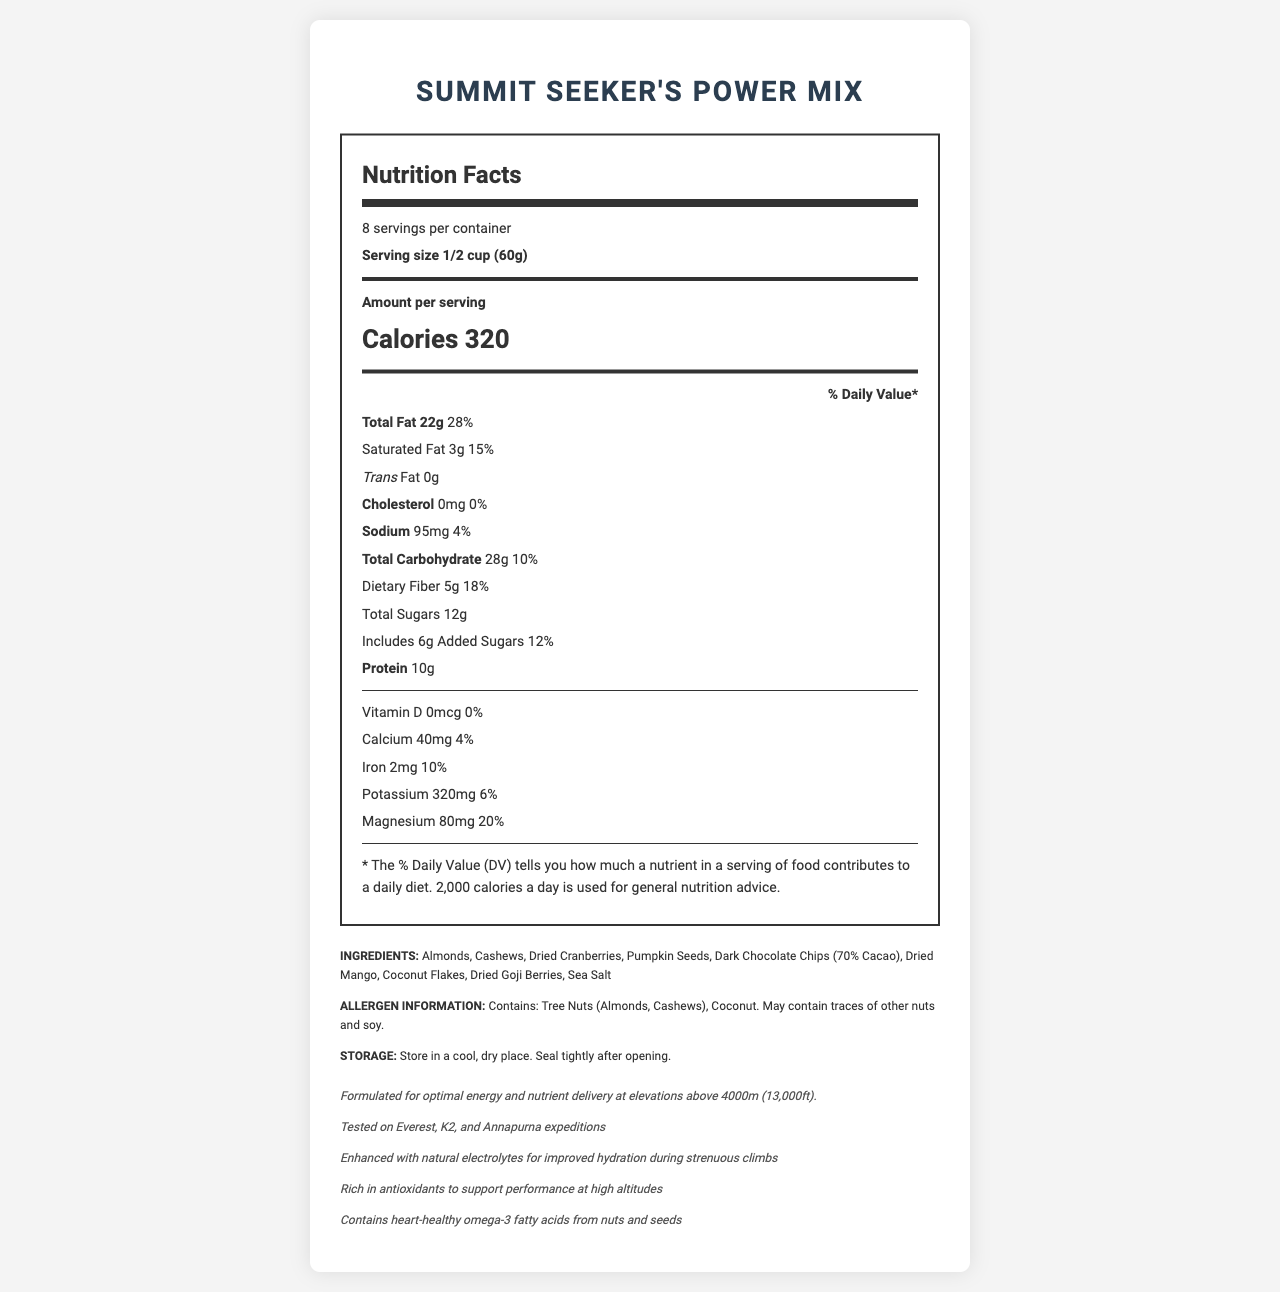what is the product name? The product name is listed at the top of the document.
Answer: Summit Seeker's Power Mix what is the serving size? The serving size is specified as "1/2 cup (60g)" in the document.
Answer: 1/2 cup (60g) how many calories are in one serving? The document indicates that there are 320 calories per serving.
Answer: 320 what is the total fat content in one serving? The total fat content is 22g, which is 28% of the daily value.
Answer: 22g (28% DV) how many servings are in one container? The document states that there are 8 servings per container.
Answer: 8 how much protein does one serving contain? The protein content per serving is 10g.
Answer: 10g is there any trans fat in this product? The document shows that the trans fat content is 0g.
Answer: No what minerals are present in the summit seeker's power mix? The nutritional part of the document lists calcium, iron, potassium, and magnesium as the minerals present.
Answer: Calcium, Iron, Potassium, Magnesium what ingredients are included in the trail mix? The ingredients section lists all these items.
Answer: Almonds, Cashews, Dried Cranberries, Pumpkin Seeds, Dark Chocolate Chips (70% Cacao), Dried Mango, Coconut Flakes, Dried Goji Berries, Sea Salt is this product suitable for someone with a nut allergy? The allergen information states that the product contains almonds, cashews, and coconut.
Answer: No which nutrient is NOT enhanced in this trail mix? A. Electrolytes B. Protein C. Omega-3 fatty acids D. Vitamin D The notes section mentions electrolytes and omega-3 fatty acids but specifies that Vitamin D is 0mcg (0% DV).
Answer: D. Vitamin D which expedition mountains have tested this product? i. Everest ii. K2 iii. Annapurna iv. Denali The notes indicate that the product was tested on Everest, K2, and Annapurna expeditions.
Answer: I, II, and III is it necessary to store this product in a refrigerator? The storage instructions say to store in a cool, dry place, but do not mention refrigeration.
Answer: No explain the main idea of the document The main parts of the document outline its nutrition facts, serving size, calories, ingredient list, allergen information, storage guidance, and special notes for high-altitude performance.
Answer: The document provides the nutritional information, ingredients, storage instructions, and special features of the Summit Seeker's Power Mix, a trail mix optimized for high-altitude summits. how many grams of added sugars are in one serving? The nutritional facts specify that there are 6 grams of added sugars per serving.
Answer: 6g does this trail mix contain any cholesterol? The document shows that cholesterol content is 0mg.
Answer: No what is the total carbohydrate content in one serving? The total carbohydrate content is 28g, which is 10% of the daily value.
Answer: 28g (10% DV) how much dietary fiber is in one serving? The dietary fiber content is detailed as 5g, which is 18% of the daily value.
Answer: 5g (18% DV) what percentage of daily value (% DV) does the magnesium contribute? The amount of magnesium in one serving is 80mg, which contributes 20% to the daily value.
Answer: 20% does the product contain soy? The allergen information states that the product may contain traces of nuts and soy, but it does not confirm the presence of soy explicitly.
Answer: Cannot be determined does the document mention anything about electrolytes? The notes section states that the product is enhanced with natural electrolytes for improved hydration during strenuous climbs.
Answer: Yes 